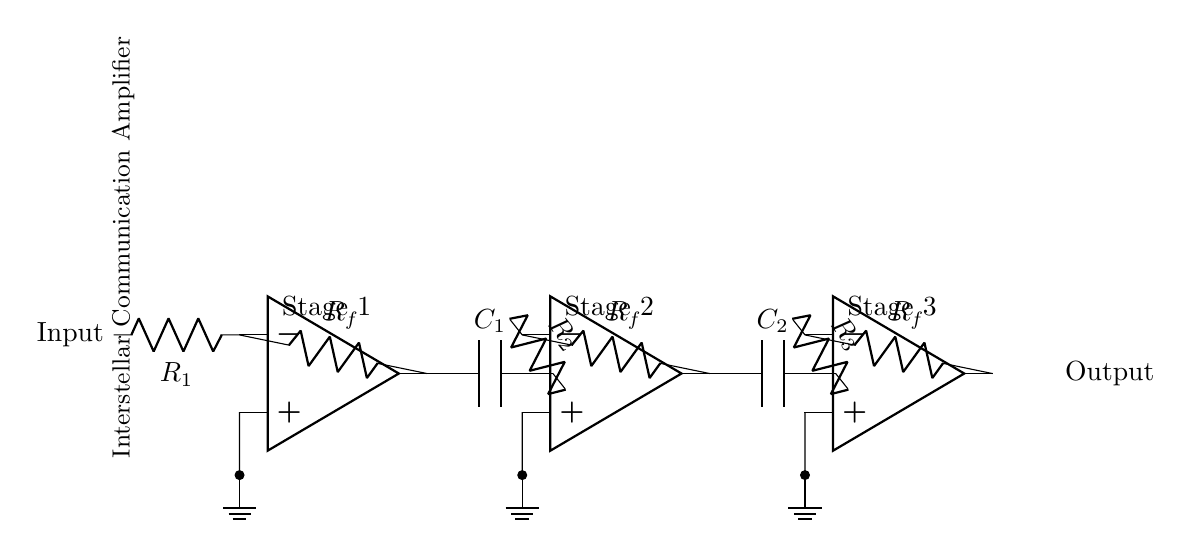What is the configuration of the amplifiers? The circuit consists of three operational amplifiers connected in a multi-stage configuration. Each amp serves to amplify the signal progressively.
Answer: Three-stage What type of components are used for coupling between stages? Coupling capacitors (C1 and C2) are used to connect each amplifier stage while blocking DC and allowing AC signals to pass through.
Answer: Capacitors What is the function of the resistors R1, R2, and R3 in the circuit? The resistors R1, R2, and R3 are used to set the gain of each operational amplifier stage by determining the feedback and input voltages.
Answer: Gain adjustment How many stages does this amplifier system have? The diagram clearly shows three stages of amplification, each represented by an operational amplifier.
Answer: Three stages What is the output point of this amplifier system? The output is taken from the third operational amplifier's output terminal, which is indicated in the circuit diagram.
Answer: Output How are the operational amplifiers powered in this diagram? The diagram symbolically connects the non-inverting terminals of the operational amplifiers to ground, implying they are powered by an external voltage source not shown in this limited representation.
Answer: Grounded (implied) What is the purpose of this multi-stage amplifier system? This system is designed to amplify weak signals for interstellar communication, ensuring manageable signal levels for transmission over long distances.
Answer: Signal amplification 